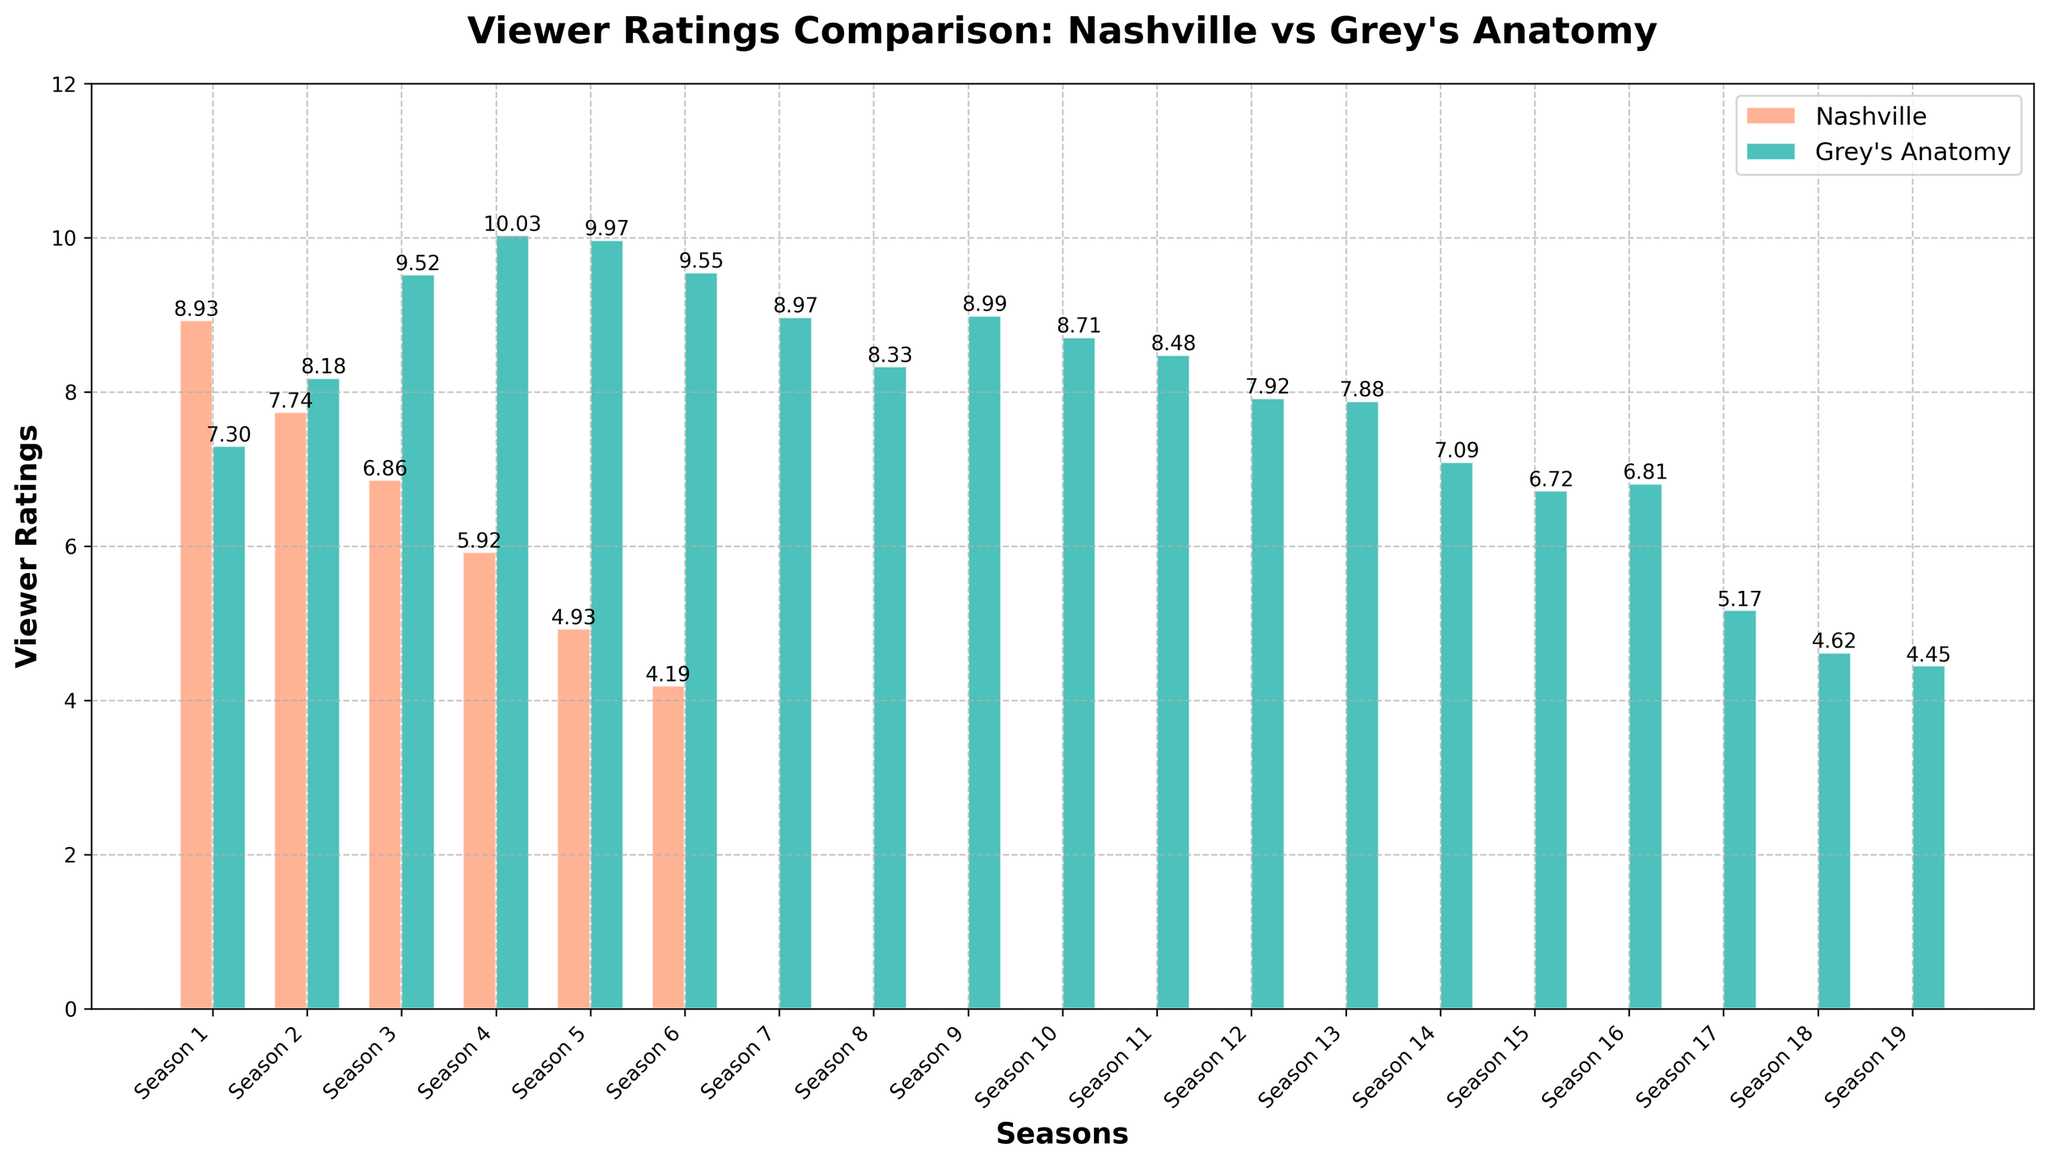What season has the highest viewer ratings for Nashville? Based on the chart, the highest bar for Nashville corresponds to Season 1.
Answer: Season 1 What season has the lowest viewer ratings for Grey's Anatomy? Based on the chart, the lowest bar for Grey's Anatomy is for Season 19.
Answer: Season 19 Comparing Season 4 of Nashville and Grey's Anatomy, which had higher viewer ratings? The chart shows that in Season 4, Nashville had a rating of around 5.92, while Grey's Anatomy had a rating of around 10.03, so Grey's Anatomy had higher ratings.
Answer: Grey's Anatomy What is the difference in viewer ratings between Nashville Season 1 and Season 2? The chart shows that Nashville Season 1 has a rating of 8.93 and Season 2 has a rating of 7.74. The difference is 8.93 - 7.74 = 1.19.
Answer: 1.19 During which season did Grey's Anatomy ratings first surpass Nashville ratings? Observing the bars for both series, Grey's Anatomy surpasses Nashville in Season 2.
Answer: Season 2 What is the average viewer rating of Nashville over all its seasons? Nashville has ratings for Seasons 1 to 6 as follows: 8.93, 7.74, 6.86, 5.92, 4.93, 4.19. The average is (8.93 + 7.74 + 6.86 + 5.92 + 4.93 + 4.19) / 6 = 6.4283.
Answer: 6.43 How does the trend of viewer ratings for Nashville change over its seasons? The bars for Nashville show a declining trend from Season 1 to Season 6.
Answer: Declining By how much do Grey's Anatomy's viewer ratings drop from Season 4 to Season 19? Grey's Anatomy ratings in Season 4 are 10.03 and in Season 19 are 4.45. The drop is 10.03 - 4.45 = 5.58.
Answer: 5.58 Which show has a more significant decrease in ratings from their highest-rated season to their lowest? Nashville's highest rating is 8.93 (Season 1) and lowest is 4.19 (Season 6), a decrease of 8.93 - 4.19 = 4.74. Grey's Anatomy's highest rating is 10.03 (Season 4) and lowest is 4.45 (Season 19), a decrease of 10.03 - 4.45 = 5.58. Therefore, Grey's Anatomy has a more significant decrease.
Answer: Grey's Anatomy 